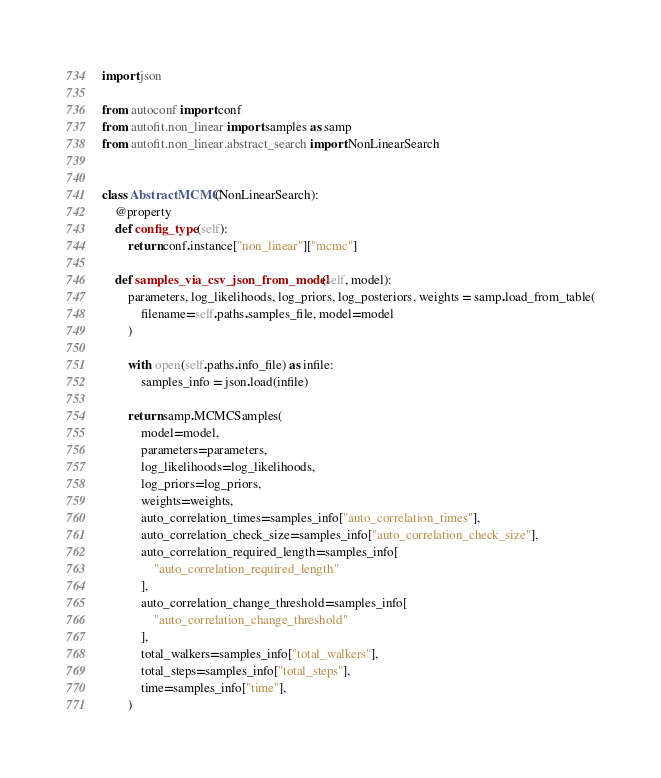Convert code to text. <code><loc_0><loc_0><loc_500><loc_500><_Python_>import json

from autoconf import conf
from autofit.non_linear import samples as samp
from autofit.non_linear.abstract_search import NonLinearSearch


class AbstractMCMC(NonLinearSearch):
    @property
    def config_type(self):
        return conf.instance["non_linear"]["mcmc"]

    def samples_via_csv_json_from_model(self, model):
        parameters, log_likelihoods, log_priors, log_posteriors, weights = samp.load_from_table(
            filename=self.paths.samples_file, model=model
        )

        with open(self.paths.info_file) as infile:
            samples_info = json.load(infile)

        return samp.MCMCSamples(
            model=model,
            parameters=parameters,
            log_likelihoods=log_likelihoods,
            log_priors=log_priors,
            weights=weights,
            auto_correlation_times=samples_info["auto_correlation_times"],
            auto_correlation_check_size=samples_info["auto_correlation_check_size"],
            auto_correlation_required_length=samples_info[
                "auto_correlation_required_length"
            ],
            auto_correlation_change_threshold=samples_info[
                "auto_correlation_change_threshold"
            ],
            total_walkers=samples_info["total_walkers"],
            total_steps=samples_info["total_steps"],
            time=samples_info["time"],
        )
</code> 